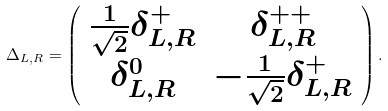<formula> <loc_0><loc_0><loc_500><loc_500>\Delta _ { L , R } = \left ( \begin{array} { c c } \frac { 1 } { \sqrt { 2 } } \delta _ { L , R } ^ { + } & \delta ^ { + + } _ { L , R } \\ \delta ^ { 0 } _ { L , R } & - \frac { 1 } { \sqrt { 2 } } \delta _ { L , R } ^ { + } \end{array} \right ) .</formula> 